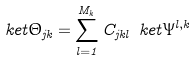<formula> <loc_0><loc_0><loc_500><loc_500>\ k e t { \Theta _ { j k } } = \sum _ { l = 1 } ^ { M _ { k } } C _ { j k l } \ k e t { \Psi ^ { l , k } }</formula> 